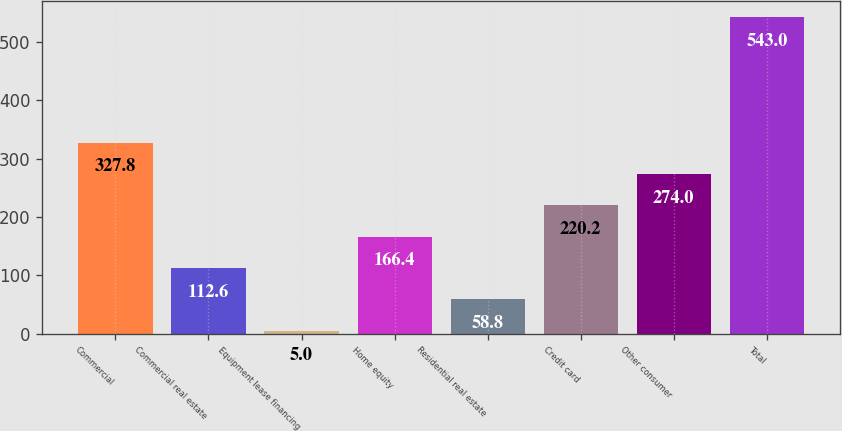<chart> <loc_0><loc_0><loc_500><loc_500><bar_chart><fcel>Commercial<fcel>Commercial real estate<fcel>Equipment lease financing<fcel>Home equity<fcel>Residential real estate<fcel>Credit card<fcel>Other consumer<fcel>Total<nl><fcel>327.8<fcel>112.6<fcel>5<fcel>166.4<fcel>58.8<fcel>220.2<fcel>274<fcel>543<nl></chart> 